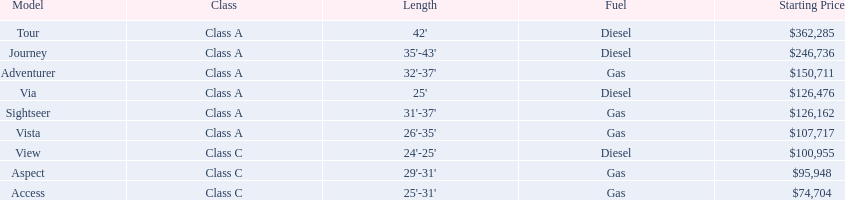In regards to starting prices, which model is the least expensive? Access. Which model ranks as the second most costly? Journey. Which model claims the highest price within the winnebago industry? Tour. 